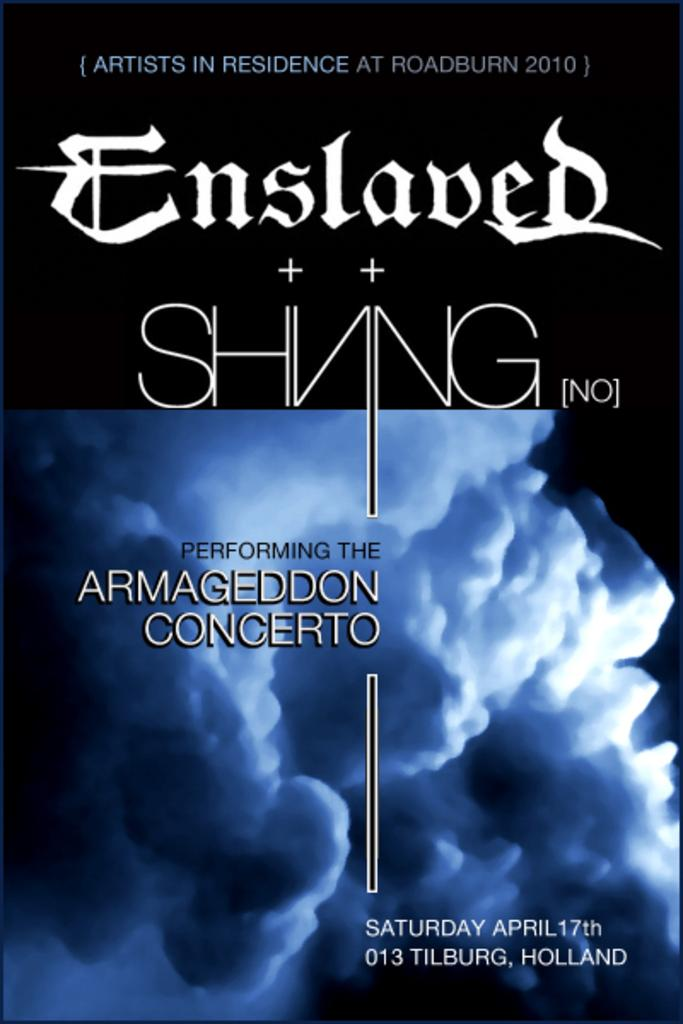<image>
Give a short and clear explanation of the subsequent image. Blue and Black poster performing Armageddon Concerto in Holland. 